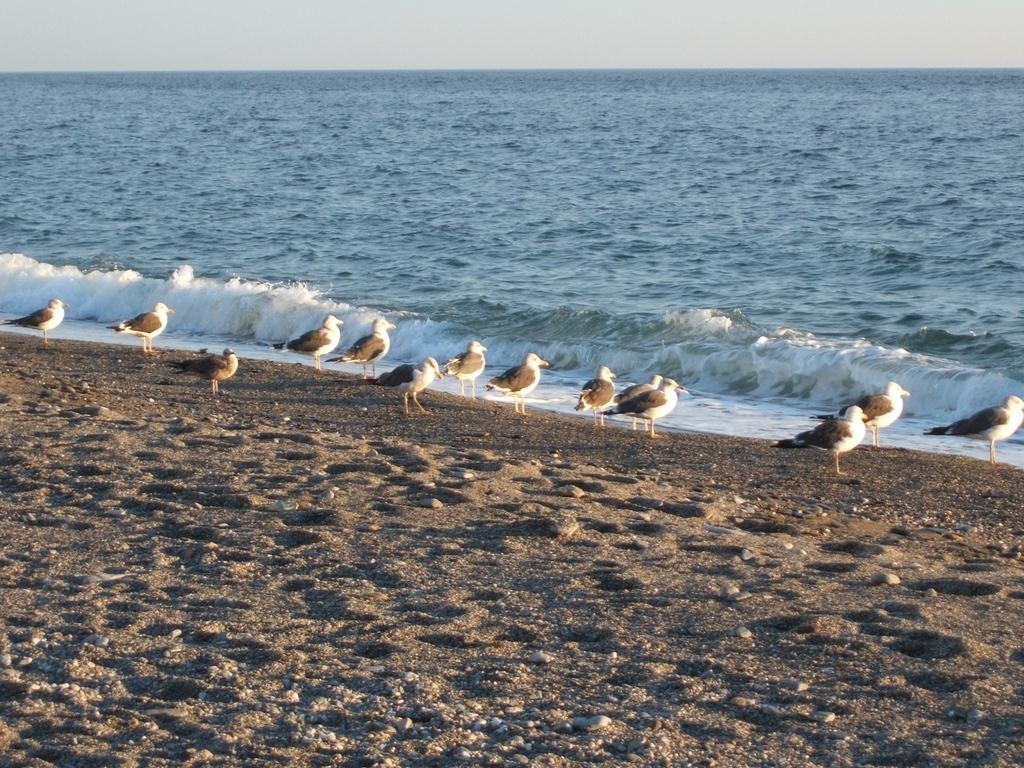What type of animals can be seen in the image? There are birds in the image. Where are the birds located in the image? The birds are standing on the sand. What else can be seen in the image besides the birds? There is water visible in the image. What type of arch can be seen in the image? There is no arch present in the image; it features birds standing on the sand and water visible in the background. 